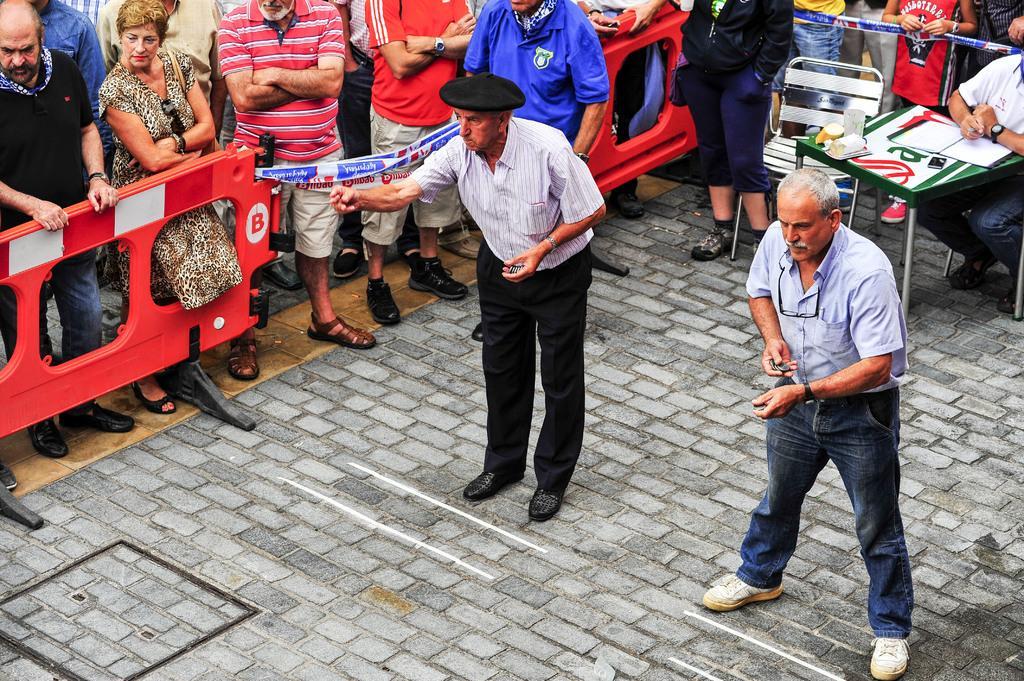Could you give a brief overview of what you see in this image? This picture describes about group of people, few are standing and a man is seated on the chair, in front of him we can see few papers, glass and other things on the table, and we can see few barricades. 